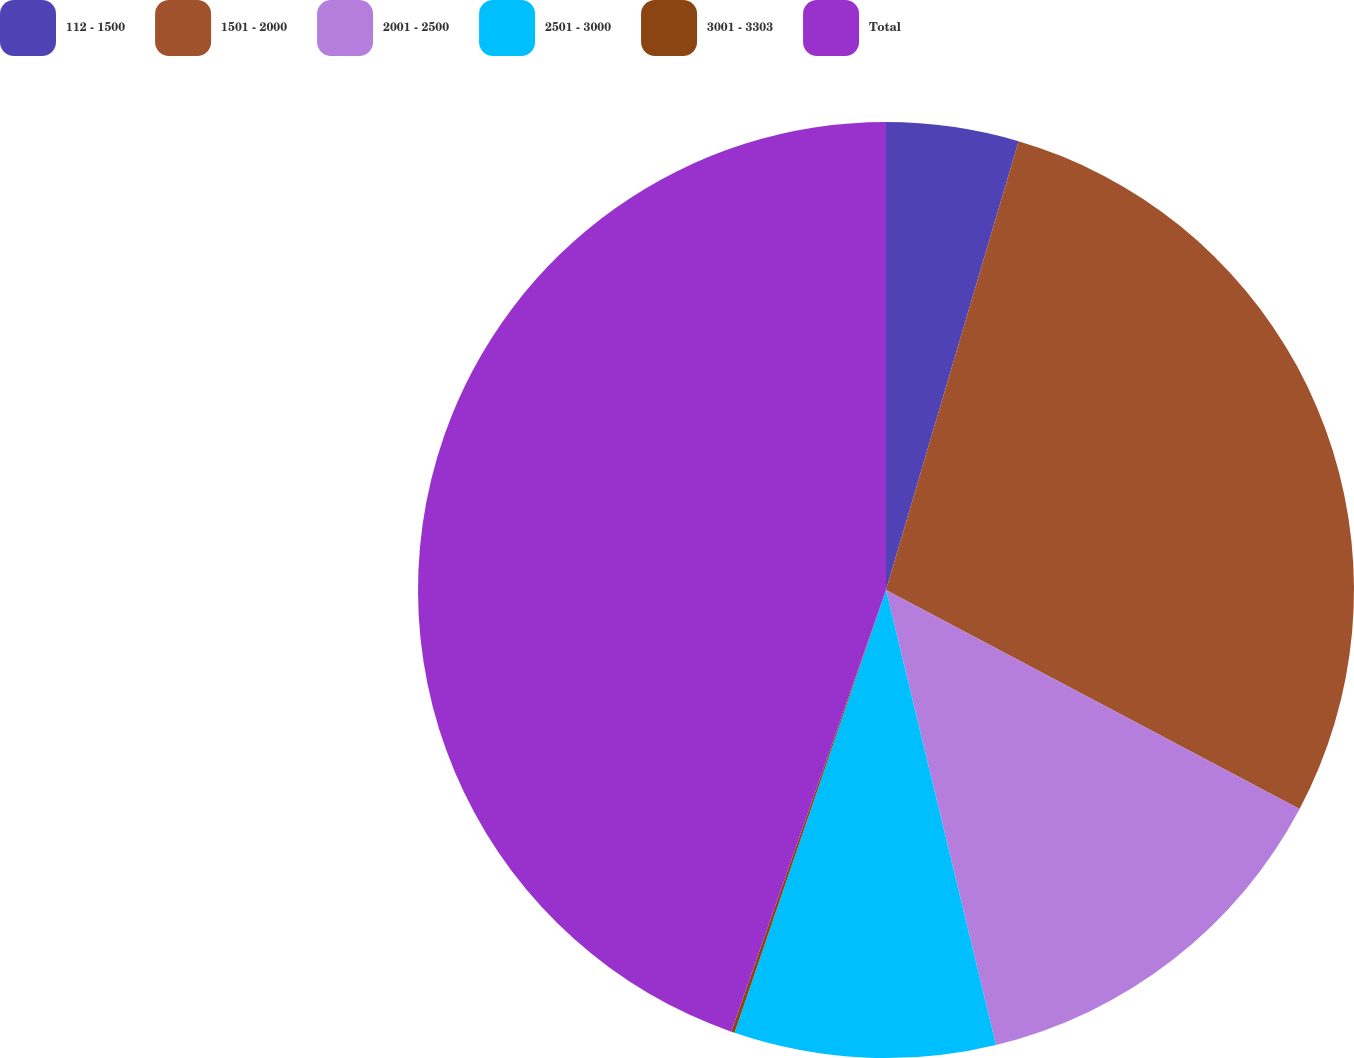Convert chart. <chart><loc_0><loc_0><loc_500><loc_500><pie_chart><fcel>112 - 1500<fcel>1501 - 2000<fcel>2001 - 2500<fcel>2501 - 3000<fcel>3001 - 3303<fcel>Total<nl><fcel>4.57%<fcel>28.18%<fcel>13.47%<fcel>9.02%<fcel>0.12%<fcel>44.63%<nl></chart> 